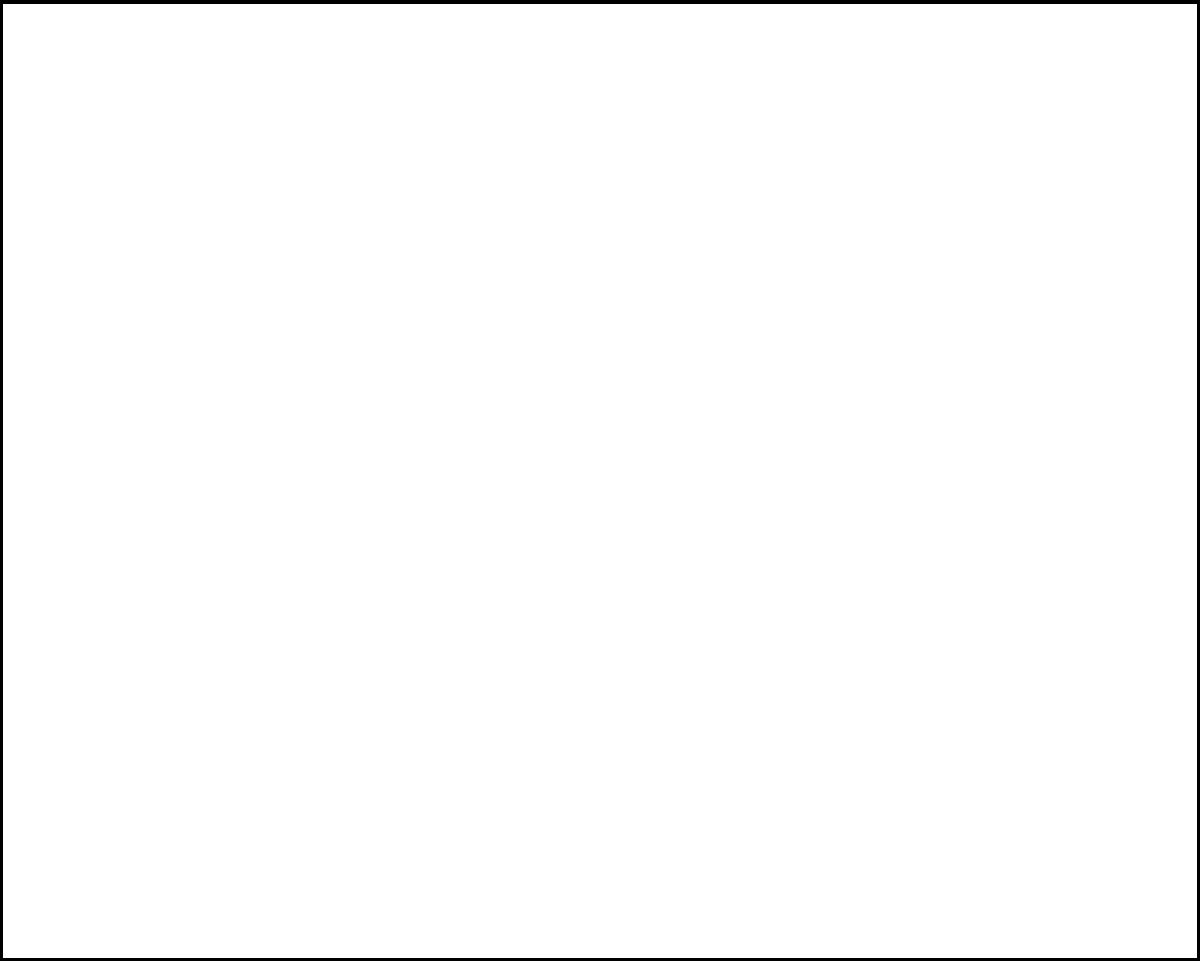As a music journalist with a background in DJing, you're writing an article about the evolution of mixing consoles. Looking at the diagram of a basic mixing console, which component would you identify as crucial for adjusting the volume levels of individual audio channels? To answer this question, let's break down the main components of the mixing console shown in the diagram:

1. The large rectangular shape represents the main body of the mixing console.

2. At the bottom of the console, we see a row of circular shapes labeled "Inputs". These are the input jacks where audio sources (like microphones or instruments) are connected.

3. In the middle section, we see three rows of small circles. These are labeled "EQ", which stands for equalizer. EQ knobs are used to adjust the frequency balance of each channel.

4. The most prominent vertical lines with circles on them are labeled "Faders". These are the volume control sliders for each individual channel.

5. At the bottom, there's a label for "Main Output", which is where the final mixed audio signal would be sent.

Given your background as a DJ and current role as a music journalist, you would recognize that the faders are the most crucial component for adjusting volume levels of individual audio channels. DJs use faders extensively to mix between different tracks, fade in and out, and balance the overall sound.

The faders allow for precise control over the volume of each input channel, which is essential in creating a balanced mix. They are typically the most frequently used controls on a mixing console, whether in a studio, live sound, or DJ setting.
Answer: Faders 